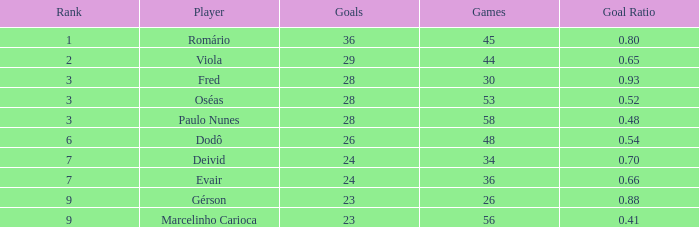8 during 56 competitions? 1.0. 